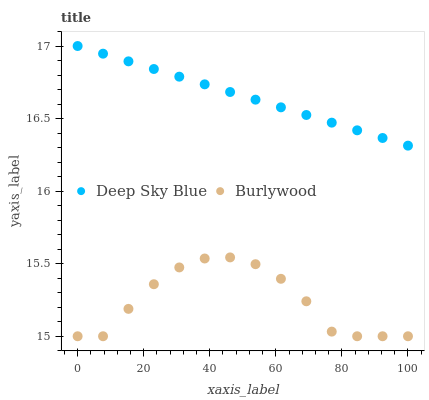Does Burlywood have the minimum area under the curve?
Answer yes or no. Yes. Does Deep Sky Blue have the maximum area under the curve?
Answer yes or no. Yes. Does Deep Sky Blue have the minimum area under the curve?
Answer yes or no. No. Is Deep Sky Blue the smoothest?
Answer yes or no. Yes. Is Burlywood the roughest?
Answer yes or no. Yes. Is Deep Sky Blue the roughest?
Answer yes or no. No. Does Burlywood have the lowest value?
Answer yes or no. Yes. Does Deep Sky Blue have the lowest value?
Answer yes or no. No. Does Deep Sky Blue have the highest value?
Answer yes or no. Yes. Is Burlywood less than Deep Sky Blue?
Answer yes or no. Yes. Is Deep Sky Blue greater than Burlywood?
Answer yes or no. Yes. Does Burlywood intersect Deep Sky Blue?
Answer yes or no. No. 